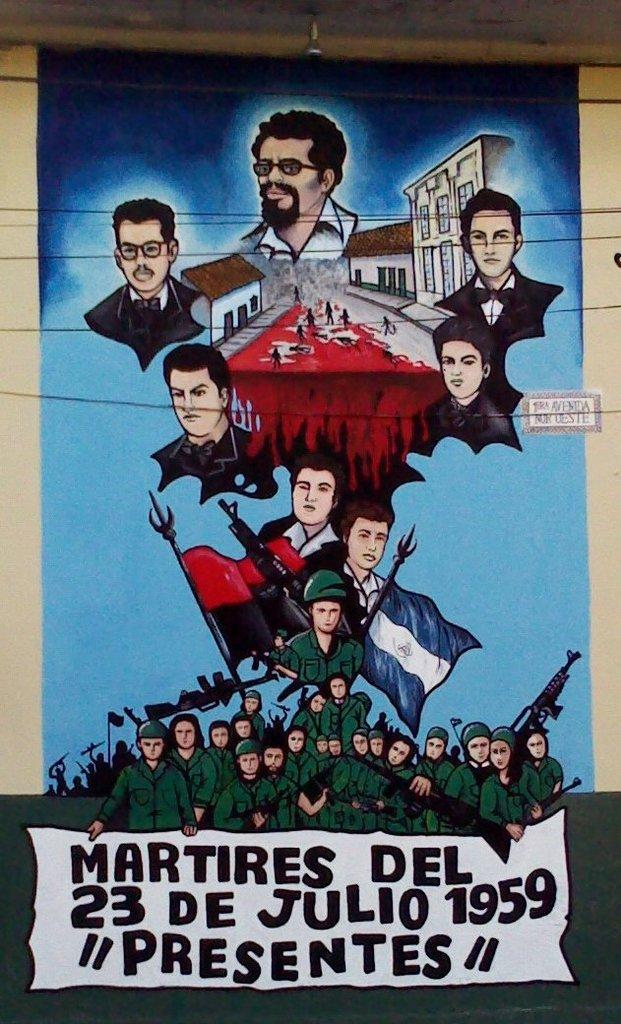<image>
Share a concise interpretation of the image provided. A brightly colored poster presenting the happenings of July 23 1959. 